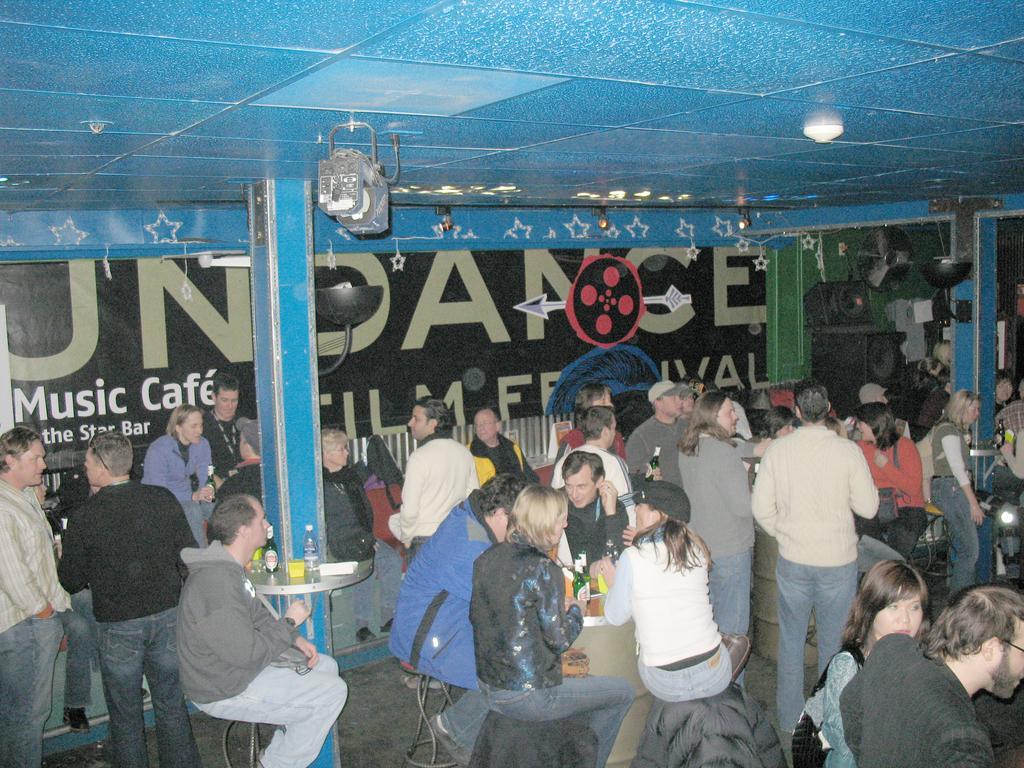Can you describe this image briefly? In this image we can see few persons are sitting on the chairs at the table and on the table there are wine bottles and we can also see few persons are standing on the floor. In the background there is a banner, wall, lights on the ceiling, speaker and other objects. 